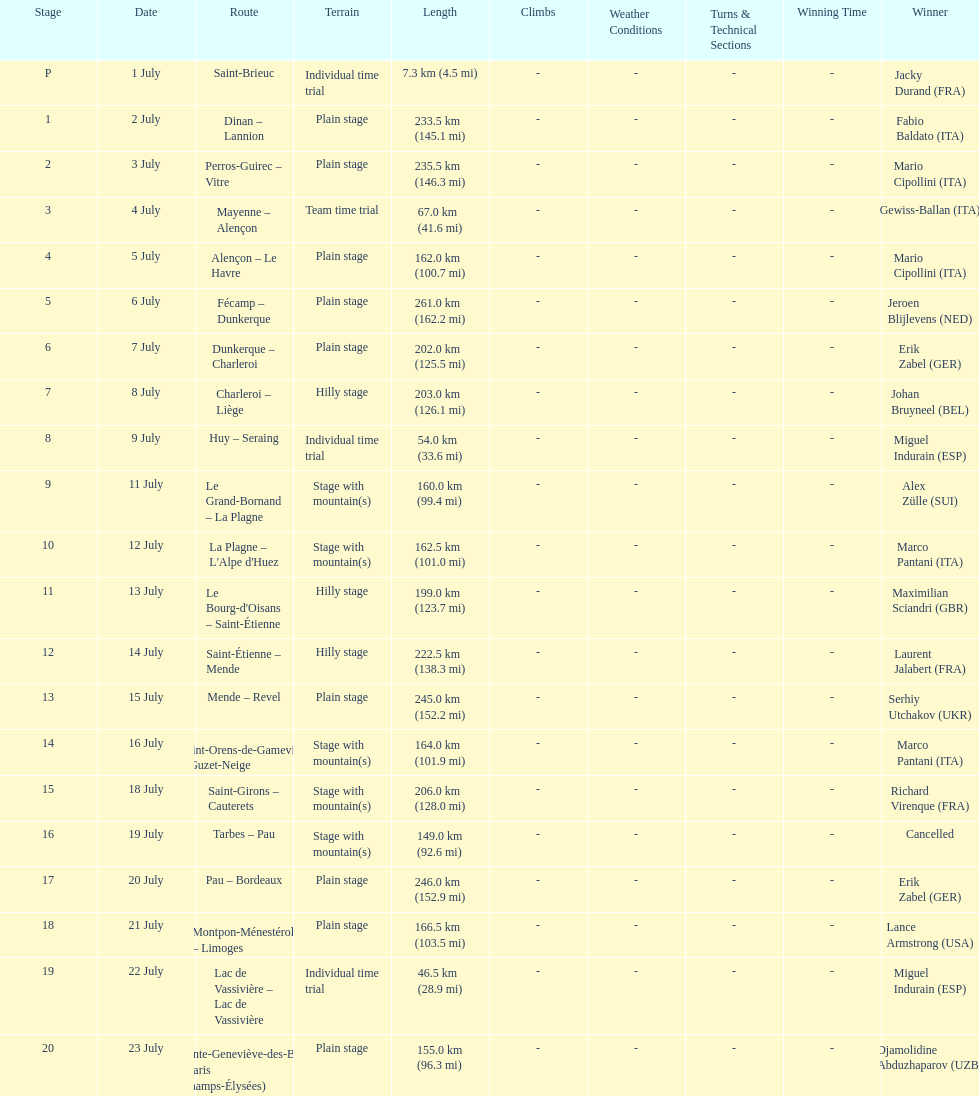Which routes were at least 100 km? Dinan - Lannion, Perros-Guirec - Vitre, Alençon - Le Havre, Fécamp - Dunkerque, Dunkerque - Charleroi, Charleroi - Liège, Le Grand-Bornand - La Plagne, La Plagne - L'Alpe d'Huez, Le Bourg-d'Oisans - Saint-Étienne, Saint-Étienne - Mende, Mende - Revel, Saint-Orens-de-Gameville - Guzet-Neige, Saint-Girons - Cauterets, Tarbes - Pau, Pau - Bordeaux, Montpon-Ménestérol - Limoges, Sainte-Geneviève-des-Bois - Paris (Champs-Élysées). 